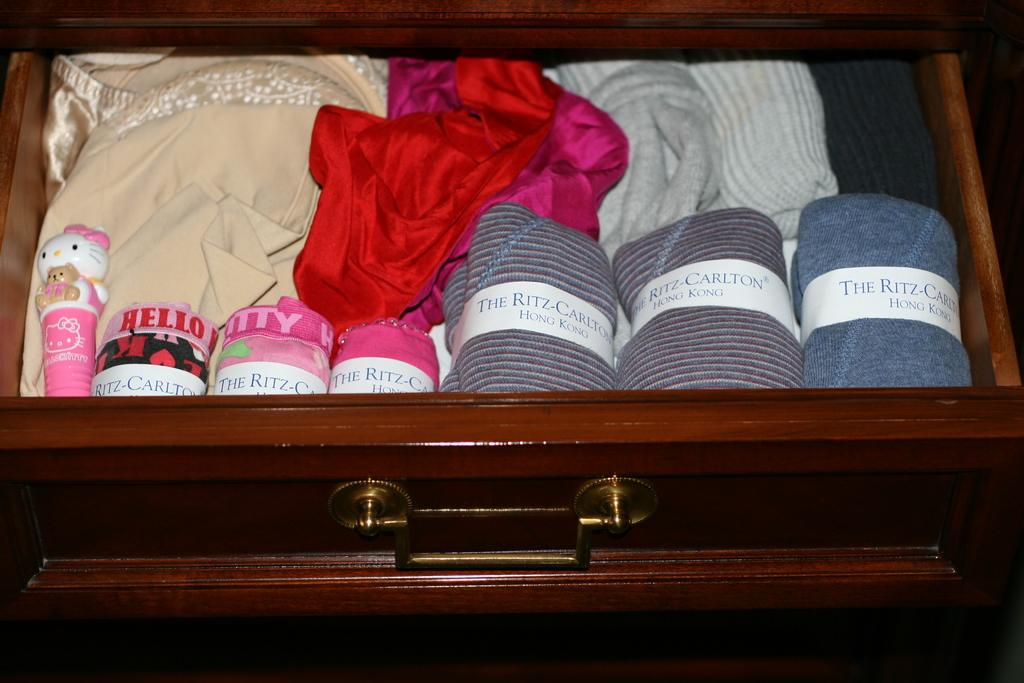<image>
Relay a brief, clear account of the picture shown. the name Carlton is on a lines shirt in a drawer 